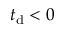<formula> <loc_0><loc_0><loc_500><loc_500>t _ { d } < 0</formula> 